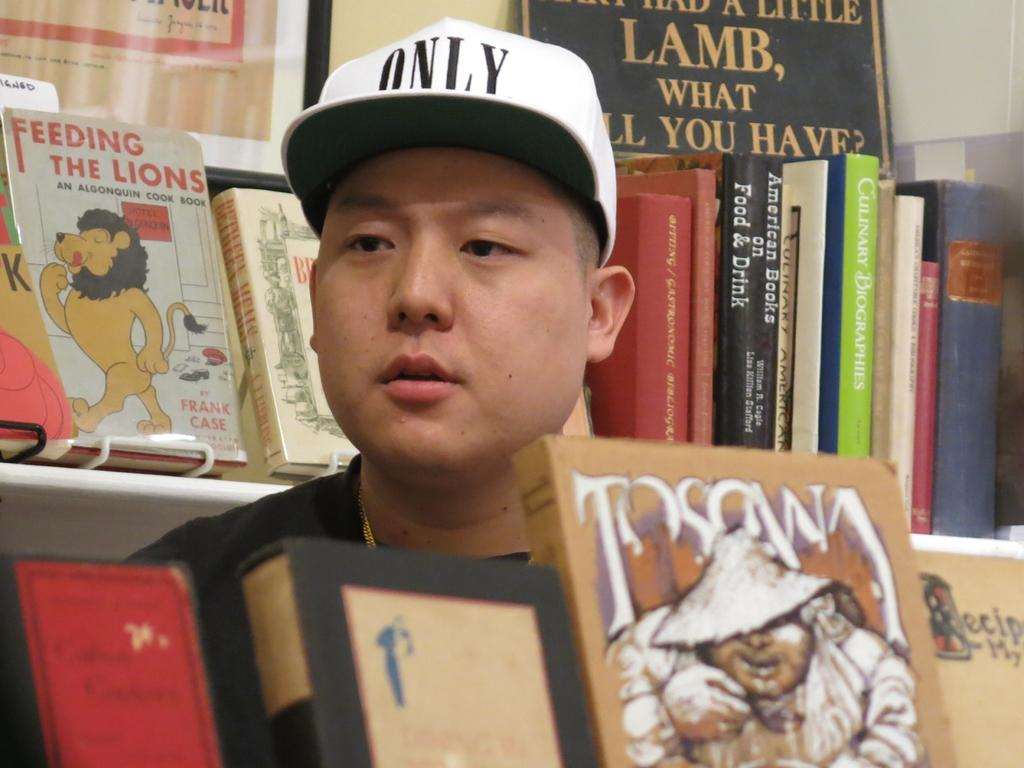Provide a one-sentence caption for the provided image. A man in a bookstore with a white hat on that says only. 